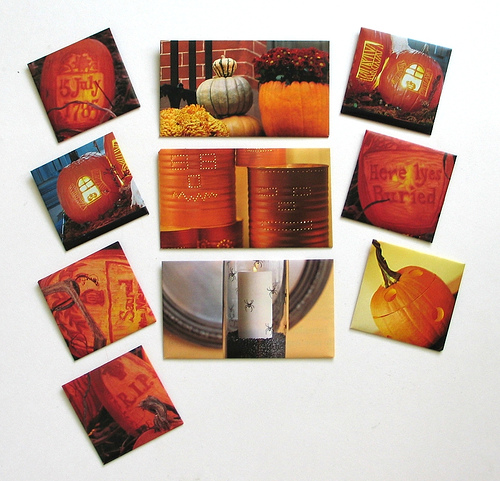<image>
Is there a spider behind the spider two? No. The spider is not behind the spider two. From this viewpoint, the spider appears to be positioned elsewhere in the scene. 